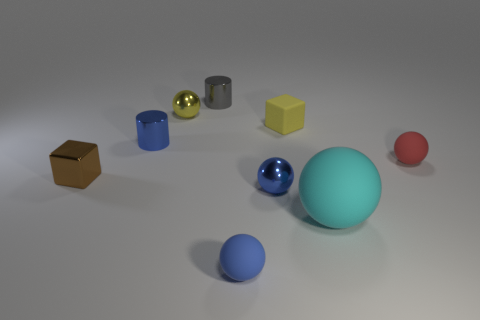Subtract all red balls. How many balls are left? 4 Subtract all brown spheres. Subtract all brown cylinders. How many spheres are left? 5 Add 1 small blue shiny things. How many objects exist? 10 Subtract all cubes. How many objects are left? 7 Add 3 cyan matte spheres. How many cyan matte spheres are left? 4 Add 2 brown things. How many brown things exist? 3 Subtract 0 purple balls. How many objects are left? 9 Subtract all big matte balls. Subtract all red rubber things. How many objects are left? 7 